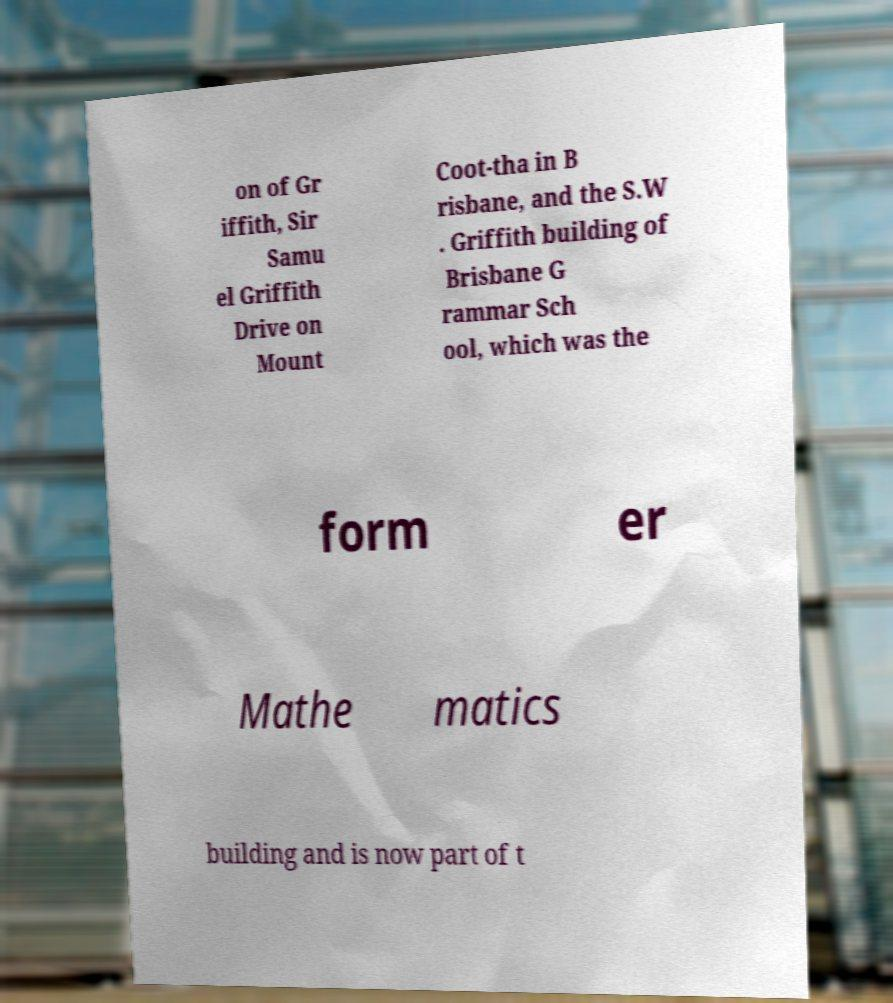For documentation purposes, I need the text within this image transcribed. Could you provide that? on of Gr iffith, Sir Samu el Griffith Drive on Mount Coot-tha in B risbane, and the S.W . Griffith building of Brisbane G rammar Sch ool, which was the form er Mathe matics building and is now part of t 